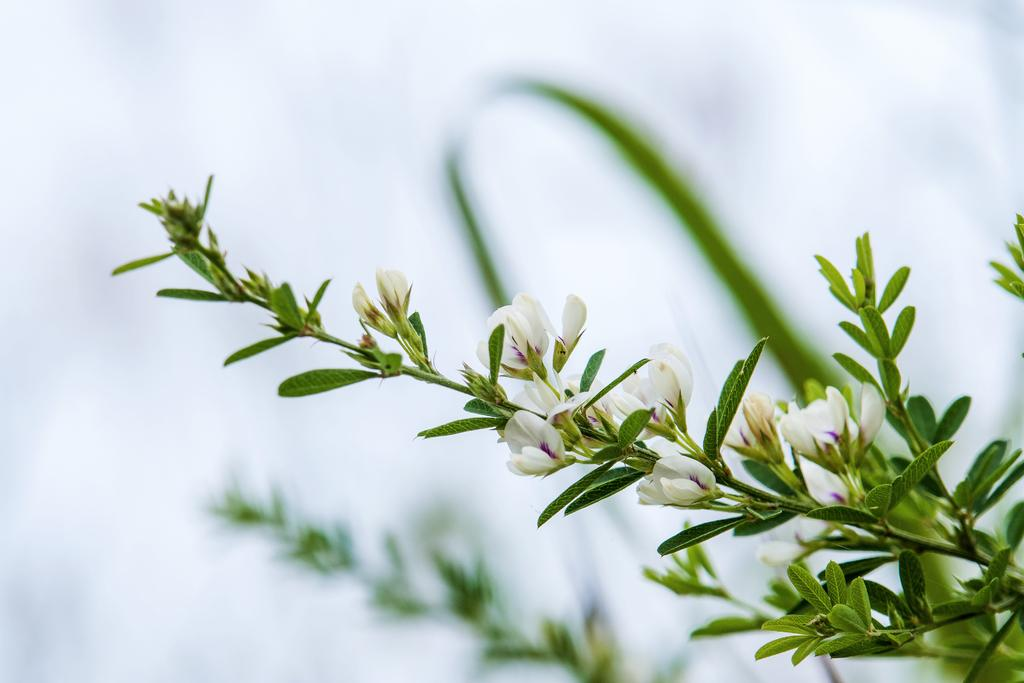How many plants are visible in the image? There are two plants on the ground in the image. What color are the flowers on one of the plants? One of the plants has white flowers. What color is the background of the image? The background of the image is white. What is the price of the stew being served in the image? There is no stew present in the image, so it is not possible to determine its price. 